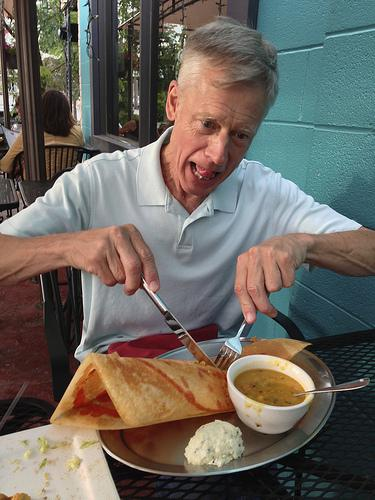Question: what is the man doing?
Choices:
A. Eating.
B. Dancing.
C. Sleeping.
D. Playing.
Answer with the letter. Answer: A Question: where is the bowl?
Choices:
A. On the table.
B. On a tray.
C. On the plate.
D. In the oven.
Answer with the letter. Answer: C 